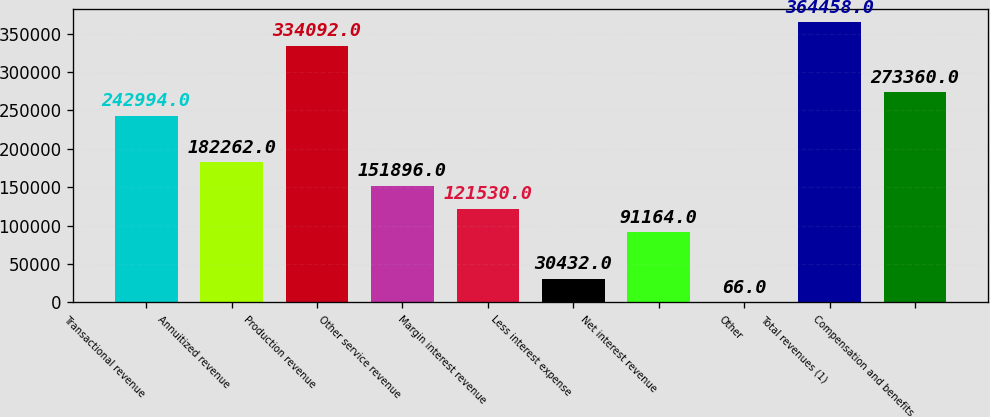<chart> <loc_0><loc_0><loc_500><loc_500><bar_chart><fcel>Transactional revenue<fcel>Annuitized revenue<fcel>Production revenue<fcel>Other service revenue<fcel>Margin interest revenue<fcel>Less interest expense<fcel>Net interest revenue<fcel>Other<fcel>Total revenues (1)<fcel>Compensation and benefits<nl><fcel>242994<fcel>182262<fcel>334092<fcel>151896<fcel>121530<fcel>30432<fcel>91164<fcel>66<fcel>364458<fcel>273360<nl></chart> 